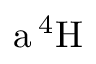Convert formula to latex. <formula><loc_0><loc_0><loc_500><loc_500>a \, ^ { 4 } H</formula> 